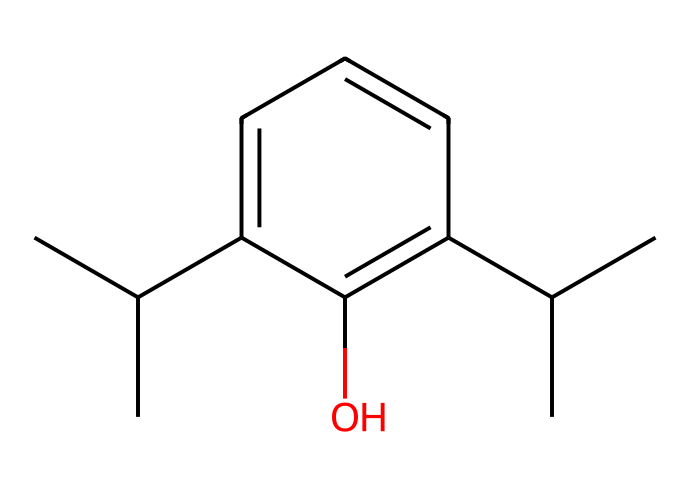What is the name of this chemical? The SMILES representation indicates a branched compound with a hydroxyl (-OH) group and multiple carbon atoms, which aligns with the structure of propofol, a commonly used anesthetic.
Answer: propofol How many carbon atoms are in propofol? Analyzing the SMILES representation, I count a total of 12 carbon atoms from the branching and aromatic structure.
Answer: 12 What functional group is present in this chemical? The structure includes a hydroxyl group (-OH), indicating that propofol has alcohol functional group characteristics.
Answer: hydroxyl What is the total number of hydrogen atoms in propofol? By examining the branching and bonding in the SMILES representation, the total number of hydrogen atoms can be counted as 18 in conjunction with the carbon atoms to satisfy their tetravalence.
Answer: 18 Is propofol considered toxic? Propofol can be toxic in certain contexts, particularly if overdosed or used improperly, but it is generally safe when administered by trained professionals.
Answer: yes What does the presence of the aromatic ring suggest about propofol? The presence of an aromatic ring indicates stability in the structure and suggests that the compound likely has characteristics of an anesthetic, such as lipophilicity, which enhances central nervous system effect.
Answer: stability 